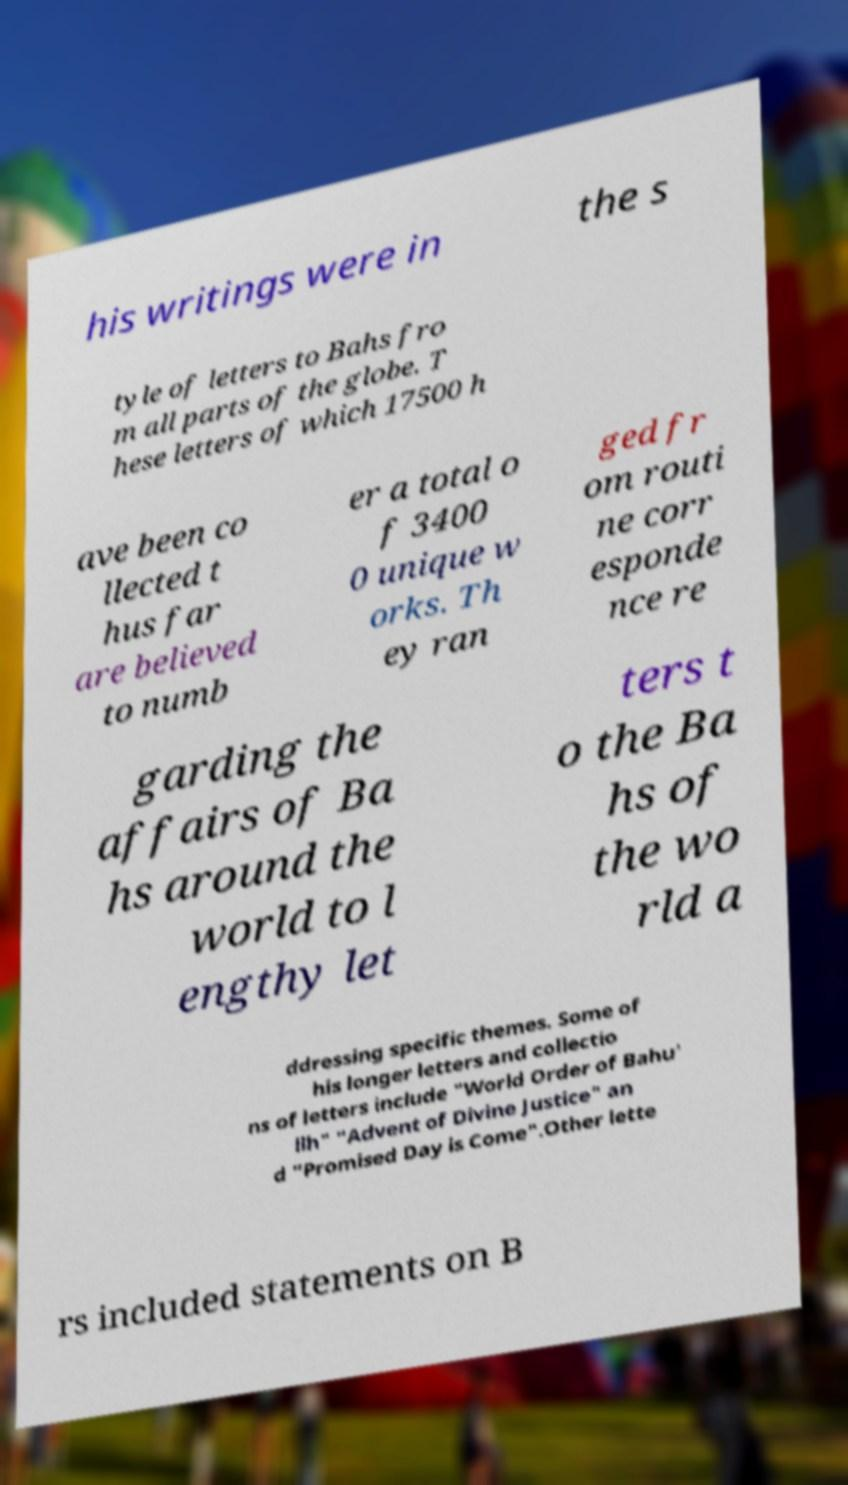What messages or text are displayed in this image? I need them in a readable, typed format. his writings were in the s tyle of letters to Bahs fro m all parts of the globe. T hese letters of which 17500 h ave been co llected t hus far are believed to numb er a total o f 3400 0 unique w orks. Th ey ran ged fr om routi ne corr esponde nce re garding the affairs of Ba hs around the world to l engthy let ters t o the Ba hs of the wo rld a ddressing specific themes. Some of his longer letters and collectio ns of letters include "World Order of Bahu' llh" "Advent of Divine Justice" an d "Promised Day is Come".Other lette rs included statements on B 